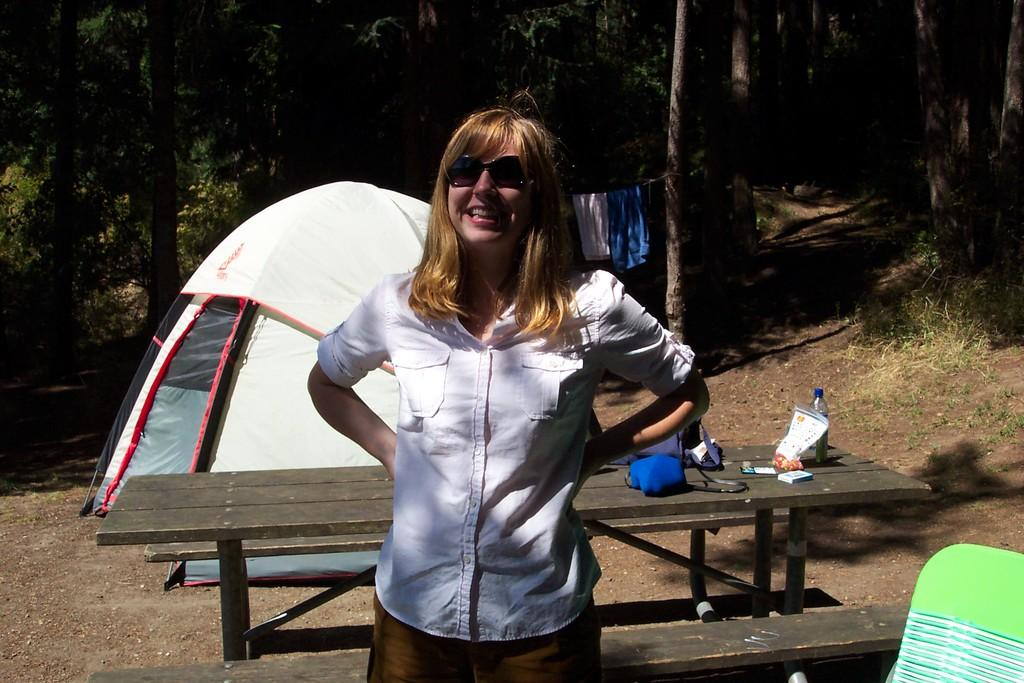Who is the main subject in the image? There is a woman in the image. What is the woman doing in the image? The woman is standing in front. What accessory is the woman wearing in the image? The woman is wearing glasses. What can be seen in the background of the image? There is a tent in the background of the image. What type of natural environment is visible in the image? There are trees all around in the image. What type of wing can be seen on the woman in the image? There is no wing visible on the woman in the image. What attraction is the woman visiting in the image? The image does not provide information about an attraction. 